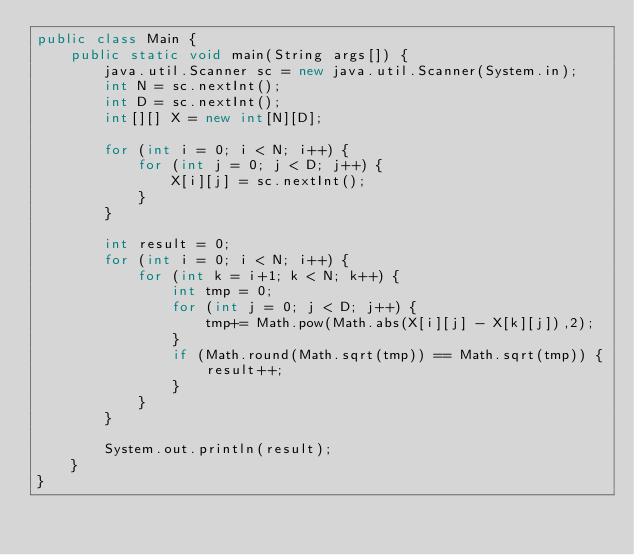<code> <loc_0><loc_0><loc_500><loc_500><_Java_>public class Main {
	public static void main(String args[]) {
		java.util.Scanner sc = new java.util.Scanner(System.in);
		int N = sc.nextInt();
		int D = sc.nextInt();
		int[][] X = new int[N][D];

		for (int i = 0; i < N; i++) {
			for (int j = 0; j < D; j++) {
				X[i][j] = sc.nextInt();
			}
		}

		int result = 0;
		for (int i = 0; i < N; i++) {
			for (int k = i+1; k < N; k++) {
				int tmp = 0;
				for (int j = 0; j < D; j++) {
					tmp+= Math.pow(Math.abs(X[i][j] - X[k][j]),2);
				}
				if (Math.round(Math.sqrt(tmp)) == Math.sqrt(tmp)) {
					result++;
				}
			}
		}

		System.out.println(result);
	}
}</code> 